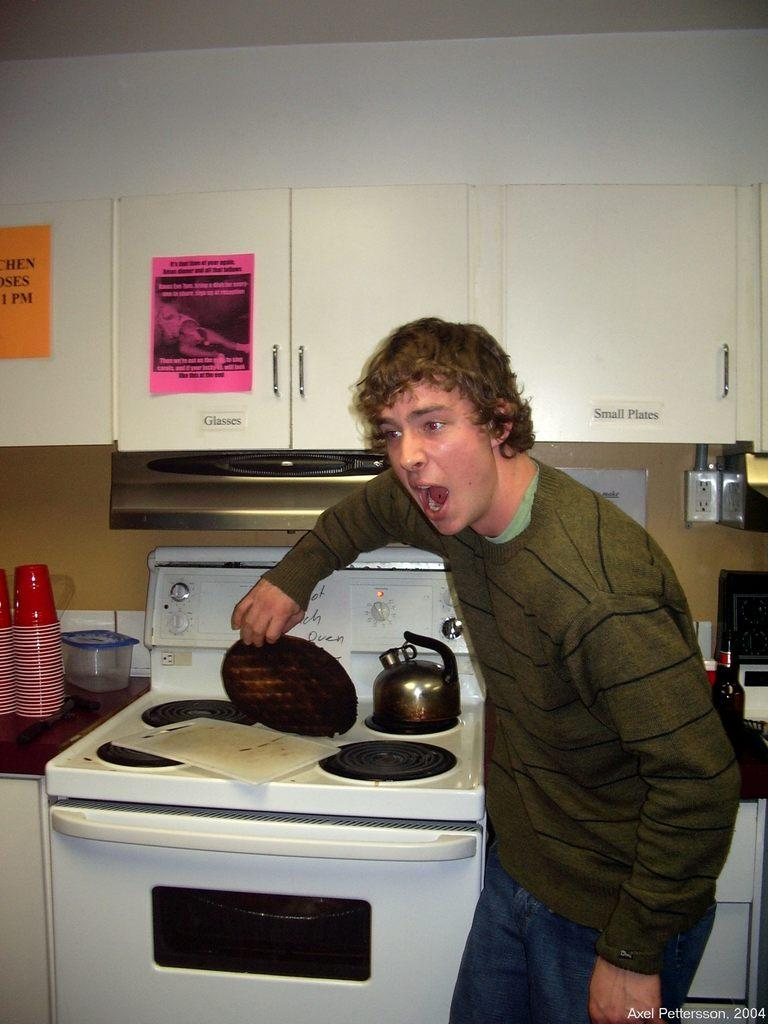<image>
Summarize the visual content of the image. A man Is posing in front of a cabinet labeled Small Plates and Glasses. 